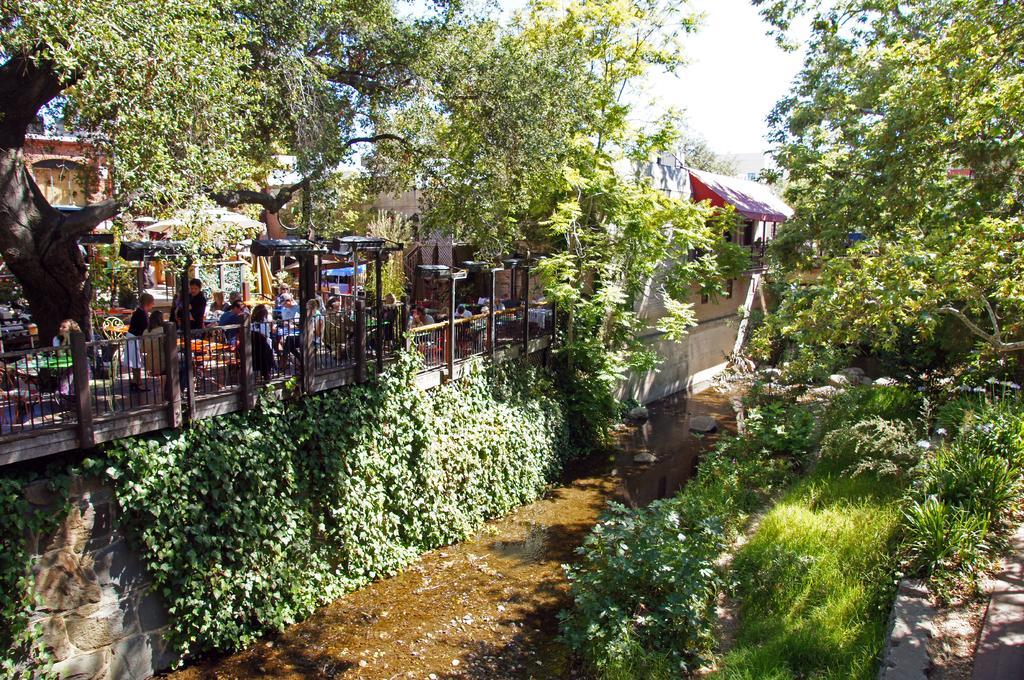Could you give a brief overview of what you see in this image? In this image there is the sky towards the top of the image, there are trees, there are plants, there is water towards the bottom of the image, there is a fencing, there is the wall, there are buildings, there are poles, there are lights, there are group of persons, there are tables, there are chairs. 